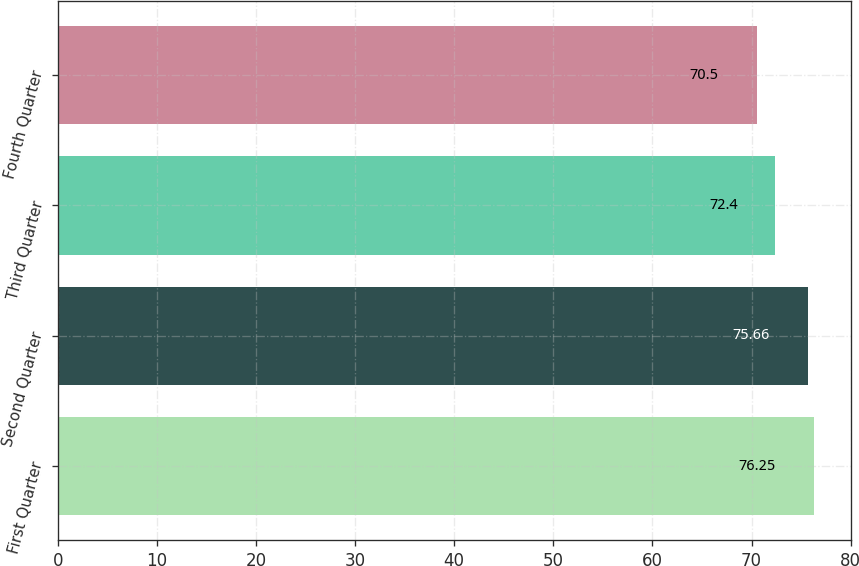<chart> <loc_0><loc_0><loc_500><loc_500><bar_chart><fcel>First Quarter<fcel>Second Quarter<fcel>Third Quarter<fcel>Fourth Quarter<nl><fcel>76.25<fcel>75.66<fcel>72.4<fcel>70.5<nl></chart> 